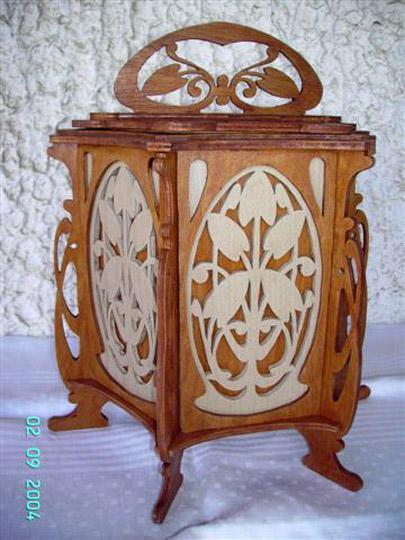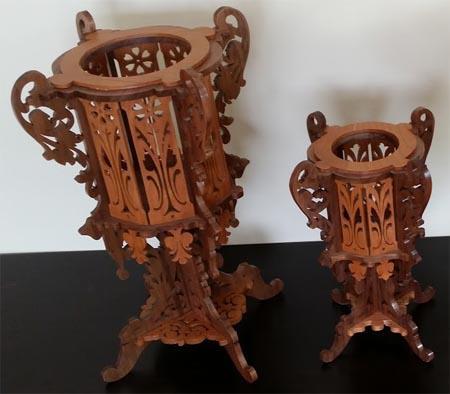The first image is the image on the left, the second image is the image on the right. Given the left and right images, does the statement "Two wooden filigree stands, one larger than the other, have a cylindrical upper section with four handles, sitting on a base with four corresponding legs." hold true? Answer yes or no. Yes. 